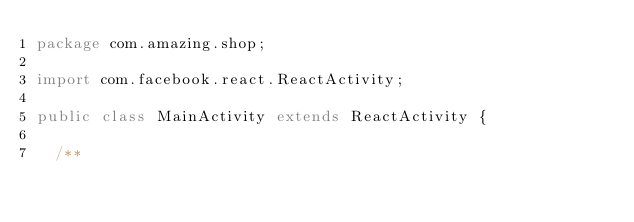Convert code to text. <code><loc_0><loc_0><loc_500><loc_500><_Java_>package com.amazing.shop;

import com.facebook.react.ReactActivity;

public class MainActivity extends ReactActivity {

  /**</code> 